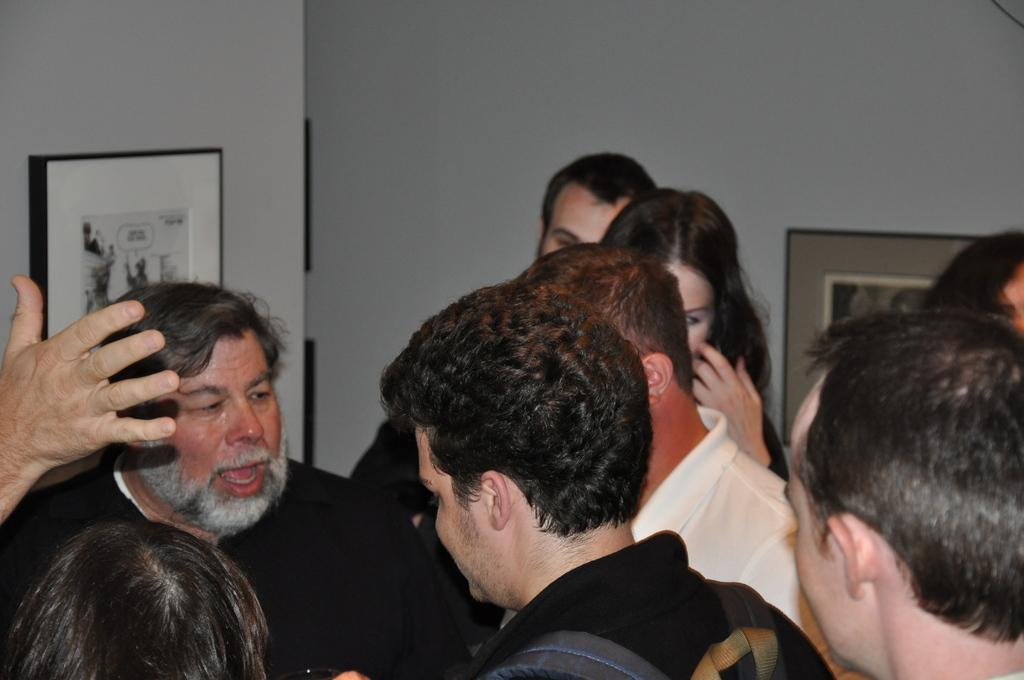How many people are in the image? There is a group of people in the image. What are the people in the image doing? The people are standing. What can be seen on the wall in the background of the image? There are photo frames on the wall in the background of the image. What type of beef is being served in the image? There is no beef present in the image; it features a group of people standing with photo frames on the wall in the background. How many sticks are being used by the people in the image? There are no sticks visible in the image; the people are standing without any objects in their hands. 